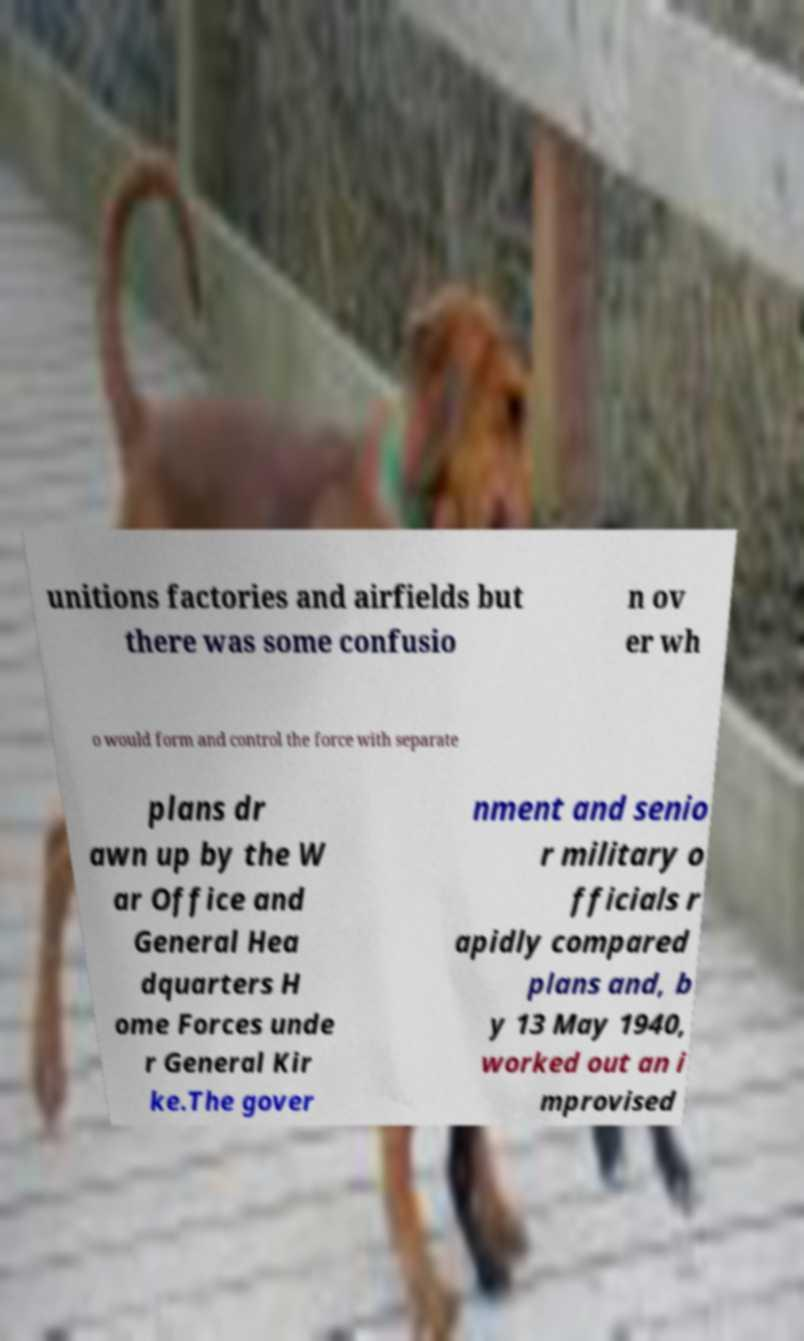Please identify and transcribe the text found in this image. unitions factories and airfields but there was some confusio n ov er wh o would form and control the force with separate plans dr awn up by the W ar Office and General Hea dquarters H ome Forces unde r General Kir ke.The gover nment and senio r military o fficials r apidly compared plans and, b y 13 May 1940, worked out an i mprovised 